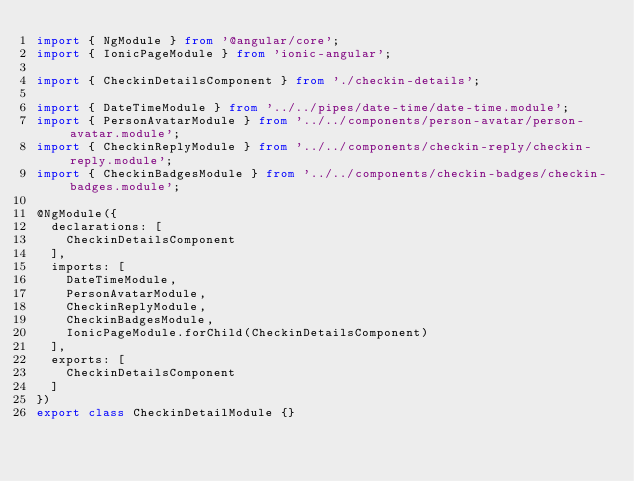<code> <loc_0><loc_0><loc_500><loc_500><_TypeScript_>import { NgModule } from '@angular/core';
import { IonicPageModule } from 'ionic-angular';

import { CheckinDetailsComponent } from './checkin-details';

import { DateTimeModule } from '../../pipes/date-time/date-time.module';
import { PersonAvatarModule } from '../../components/person-avatar/person-avatar.module';
import { CheckinReplyModule } from '../../components/checkin-reply/checkin-reply.module';
import { CheckinBadgesModule } from '../../components/checkin-badges/checkin-badges.module';

@NgModule({
  declarations: [
    CheckinDetailsComponent
  ],
  imports: [
    DateTimeModule,
    PersonAvatarModule,
    CheckinReplyModule,
    CheckinBadgesModule,
    IonicPageModule.forChild(CheckinDetailsComponent)
  ],
  exports: [
    CheckinDetailsComponent
  ]
})
export class CheckinDetailModule {}
</code> 